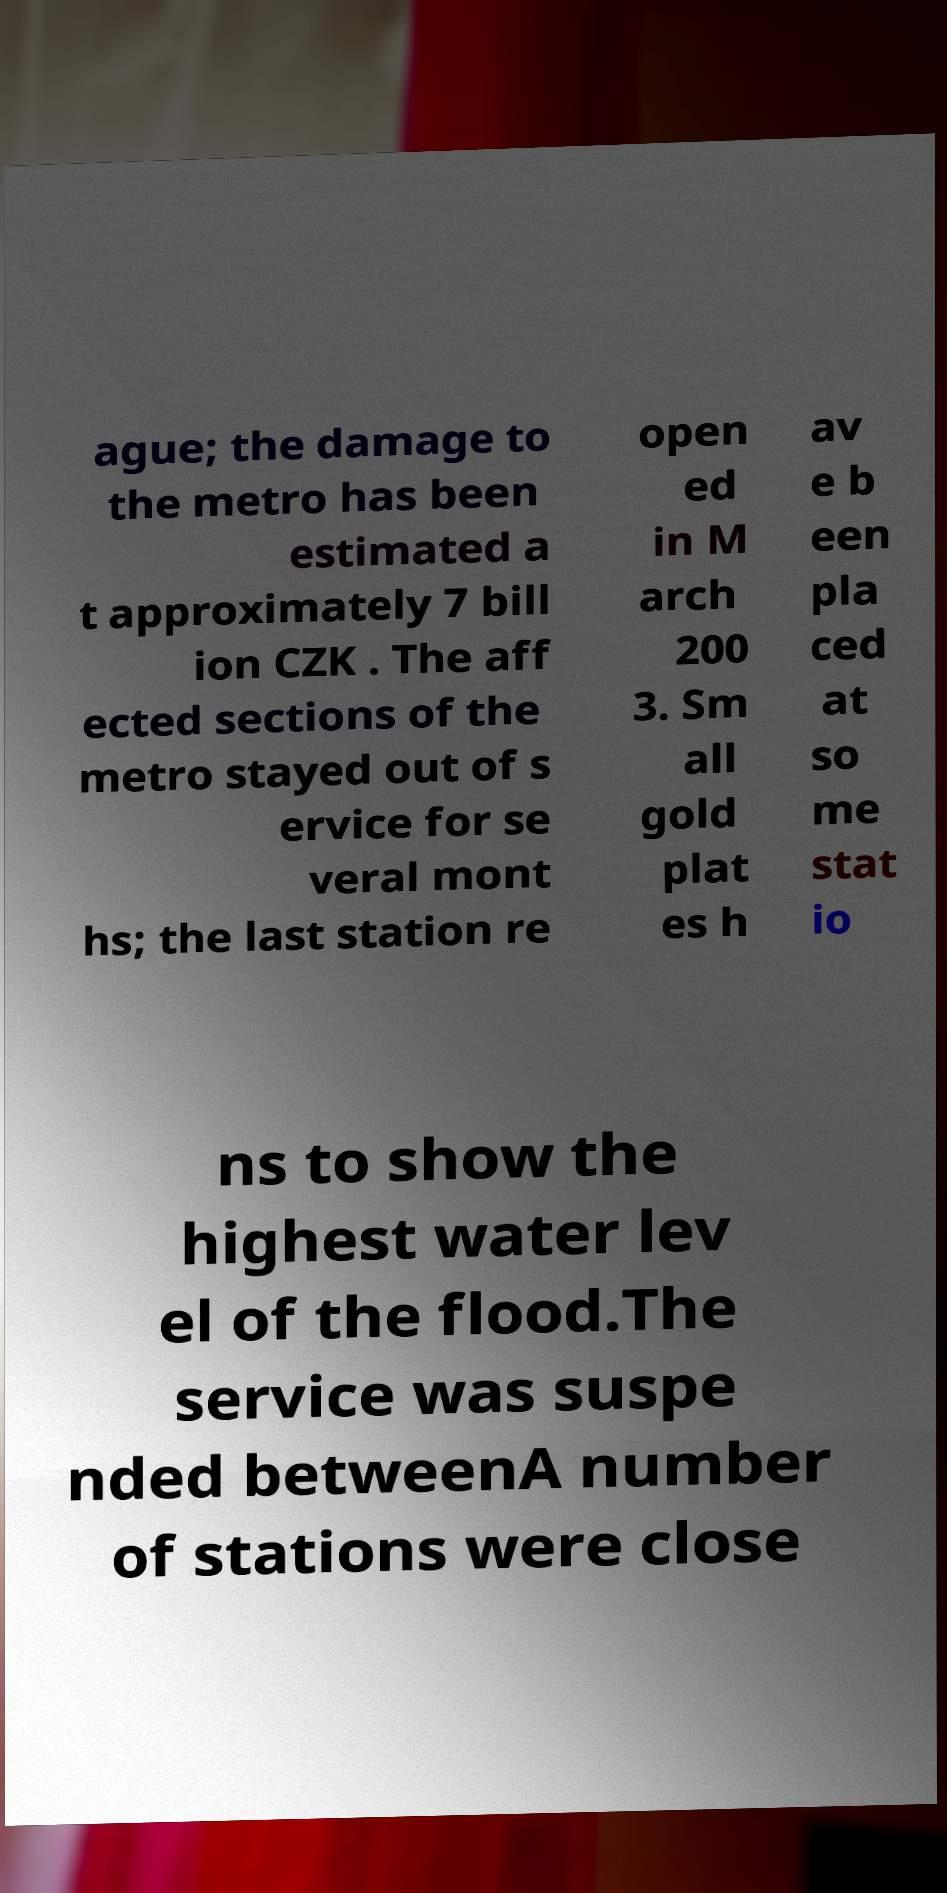There's text embedded in this image that I need extracted. Can you transcribe it verbatim? ague; the damage to the metro has been estimated a t approximately 7 bill ion CZK . The aff ected sections of the metro stayed out of s ervice for se veral mont hs; the last station re open ed in M arch 200 3. Sm all gold plat es h av e b een pla ced at so me stat io ns to show the highest water lev el of the flood.The service was suspe nded betweenA number of stations were close 